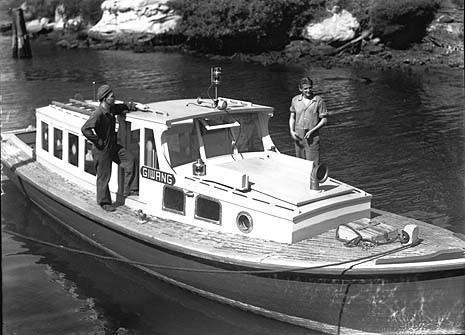How many boats are there?
Give a very brief answer. 1. How many people are in the picture?
Give a very brief answer. 2. 